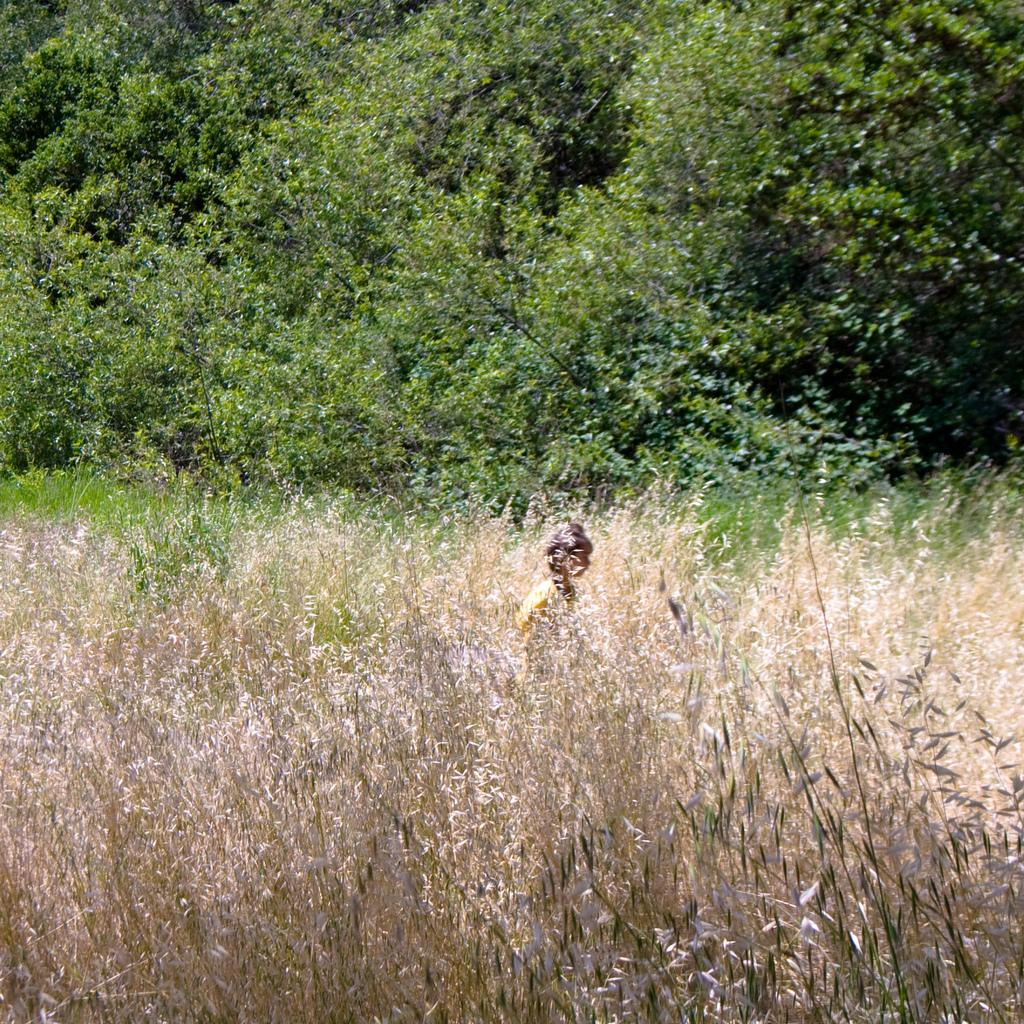What type of vegetation is in the front of the image? There is dry grass in the front of the image. What is the main subject in the center of the image? There is a person in the center of the image. What can be seen in the background of the image? There are trees in the background of the image. What type of authority figure can be seen in the image? There is no authority figure present in the image; it features dry grass, a person, and trees. Can you describe the mist in the image? There is no mist present in the image. 